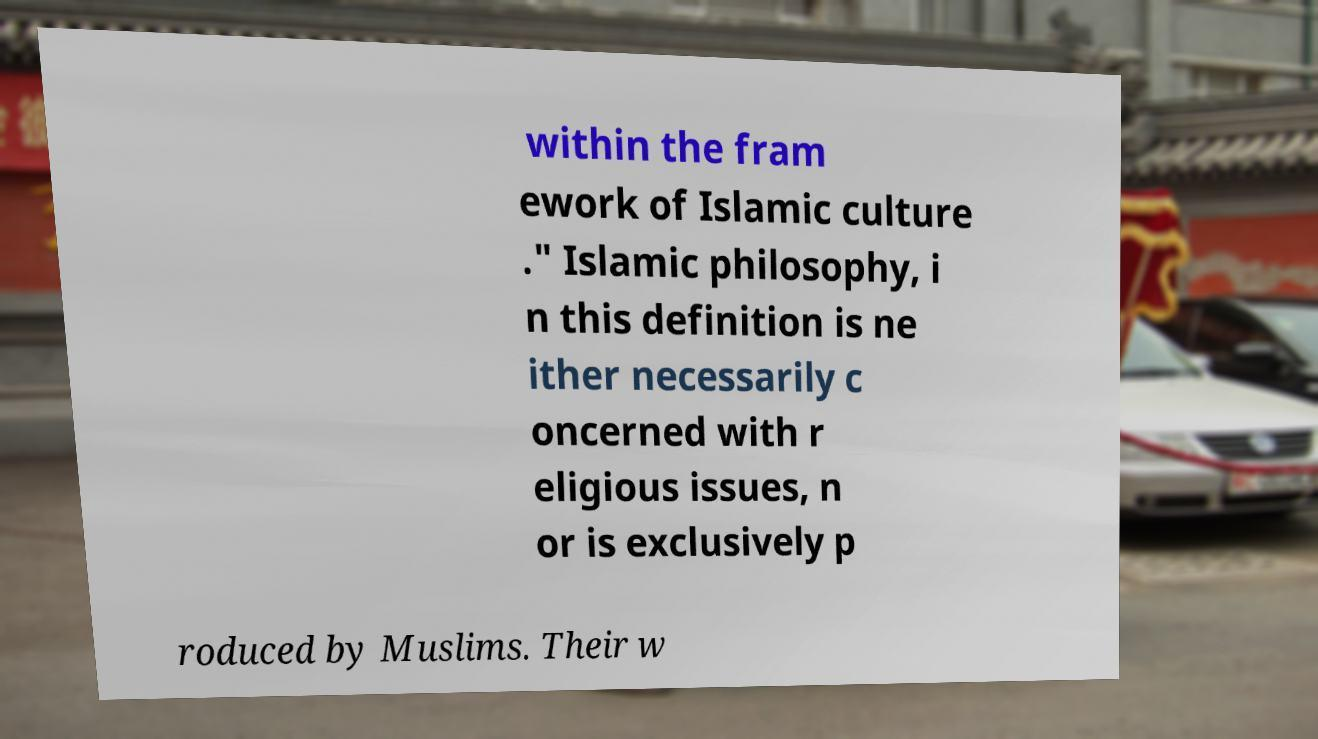Could you extract and type out the text from this image? within the fram ework of Islamic culture ." Islamic philosophy, i n this definition is ne ither necessarily c oncerned with r eligious issues, n or is exclusively p roduced by Muslims. Their w 